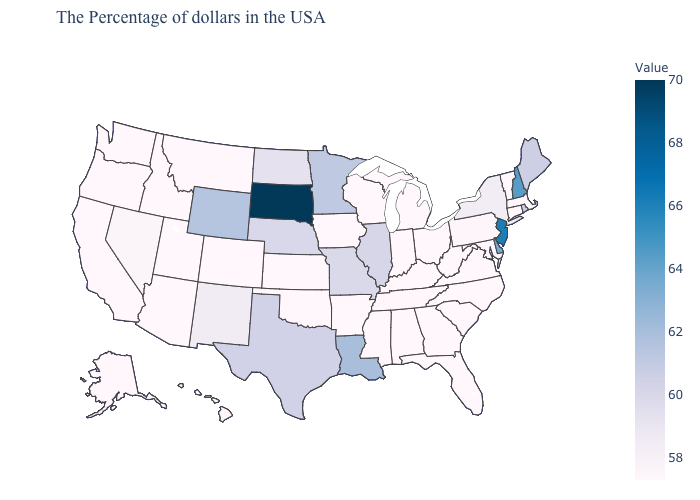Among the states that border Kentucky , does West Virginia have the lowest value?
Give a very brief answer. Yes. 